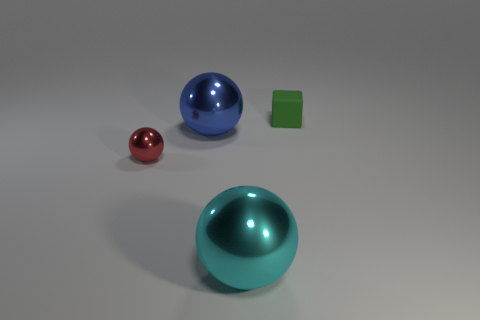Add 3 tiny green things. How many objects exist? 7 Subtract all balls. How many objects are left? 1 Subtract 0 brown balls. How many objects are left? 4 Subtract all small green blocks. Subtract all big things. How many objects are left? 1 Add 4 metal spheres. How many metal spheres are left? 7 Add 1 large blue objects. How many large blue objects exist? 2 